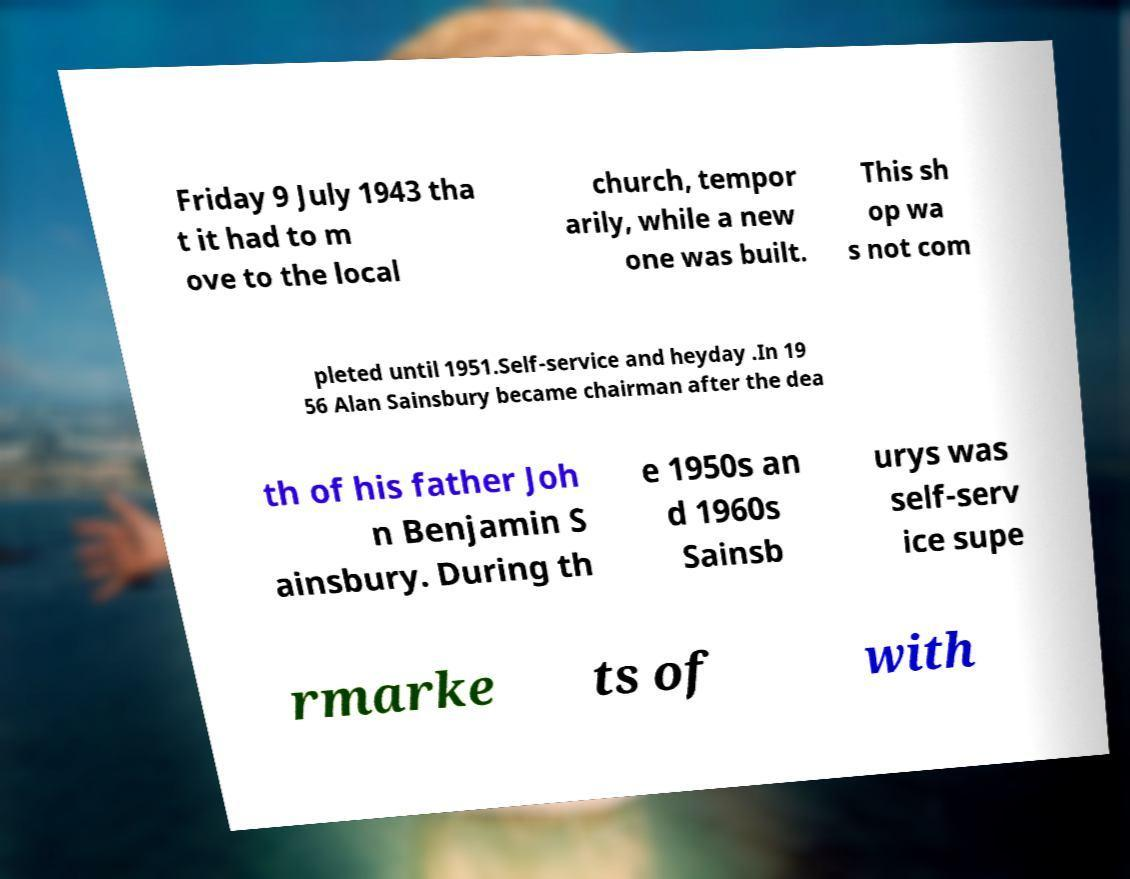What messages or text are displayed in this image? I need them in a readable, typed format. Friday 9 July 1943 tha t it had to m ove to the local church, tempor arily, while a new one was built. This sh op wa s not com pleted until 1951.Self-service and heyday .In 19 56 Alan Sainsbury became chairman after the dea th of his father Joh n Benjamin S ainsbury. During th e 1950s an d 1960s Sainsb urys was self-serv ice supe rmarke ts of with 